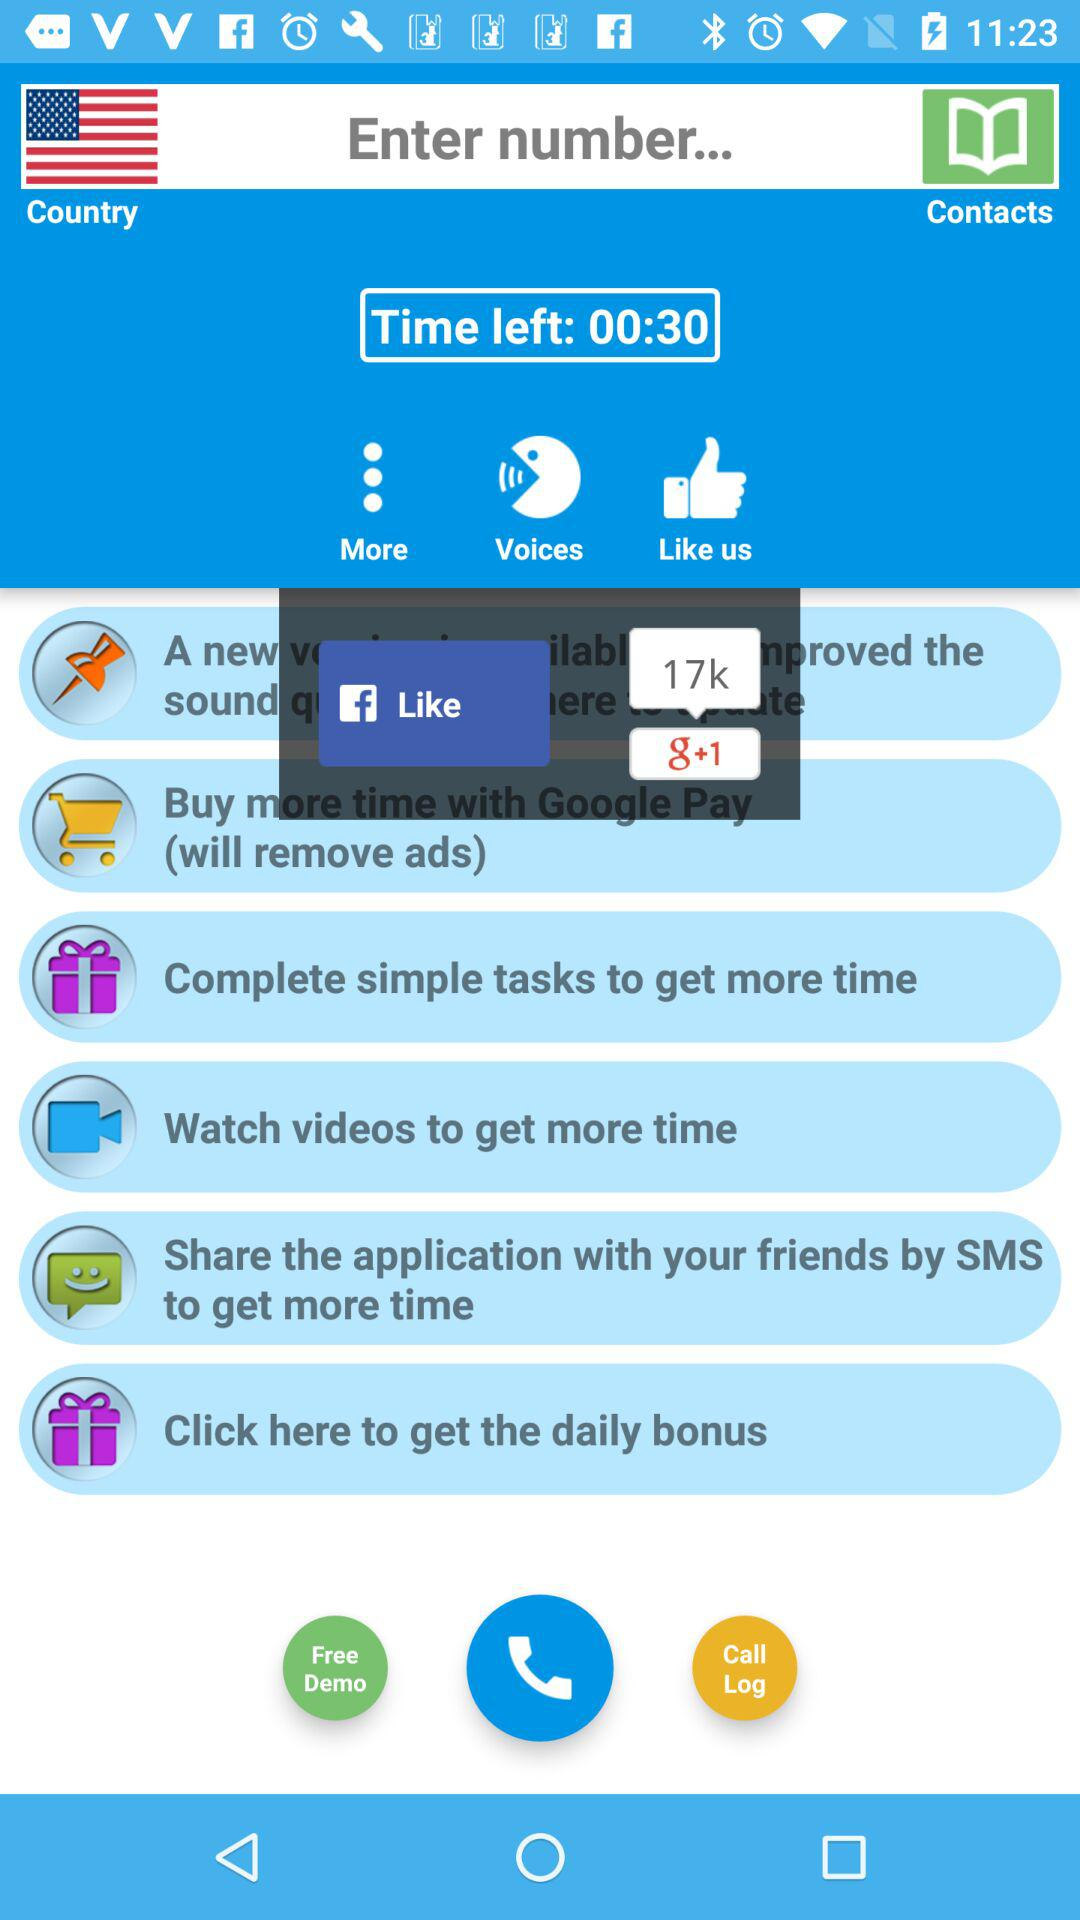How much time is left on the timer?
Answer the question using a single word or phrase. 00:30 